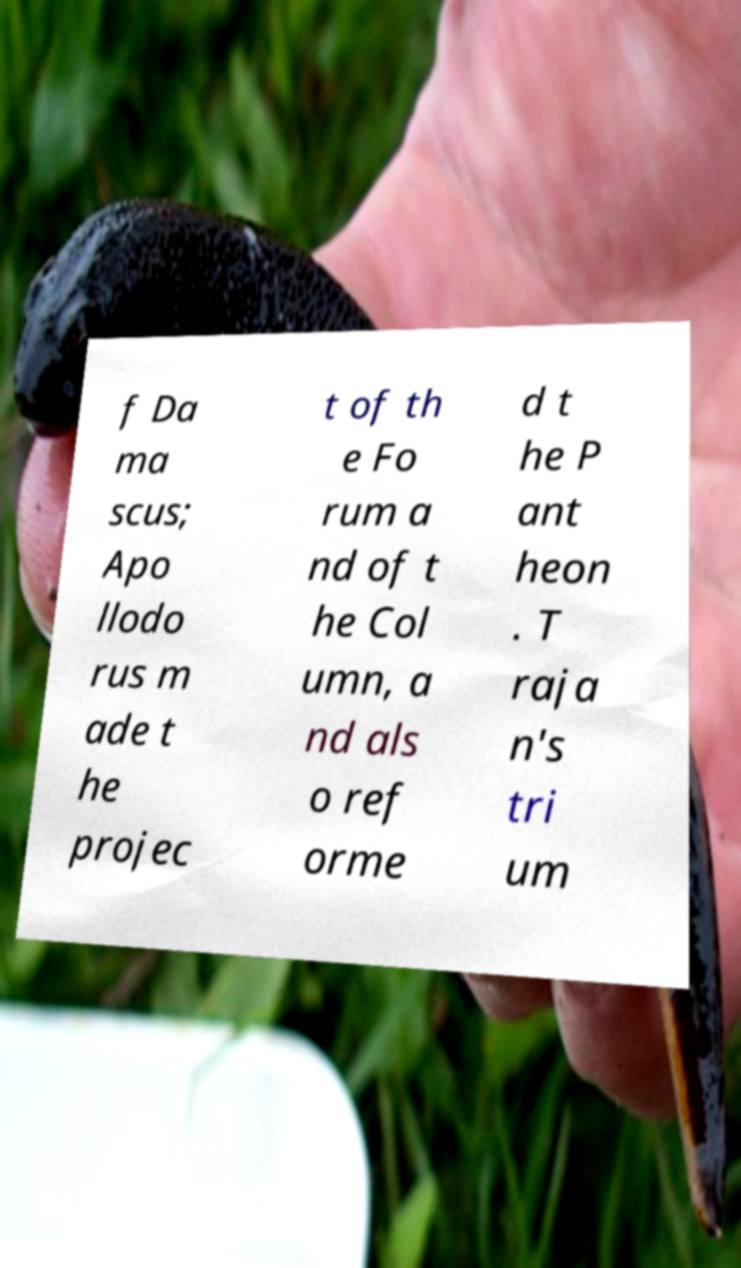Can you read and provide the text displayed in the image?This photo seems to have some interesting text. Can you extract and type it out for me? f Da ma scus; Apo llodo rus m ade t he projec t of th e Fo rum a nd of t he Col umn, a nd als o ref orme d t he P ant heon . T raja n's tri um 